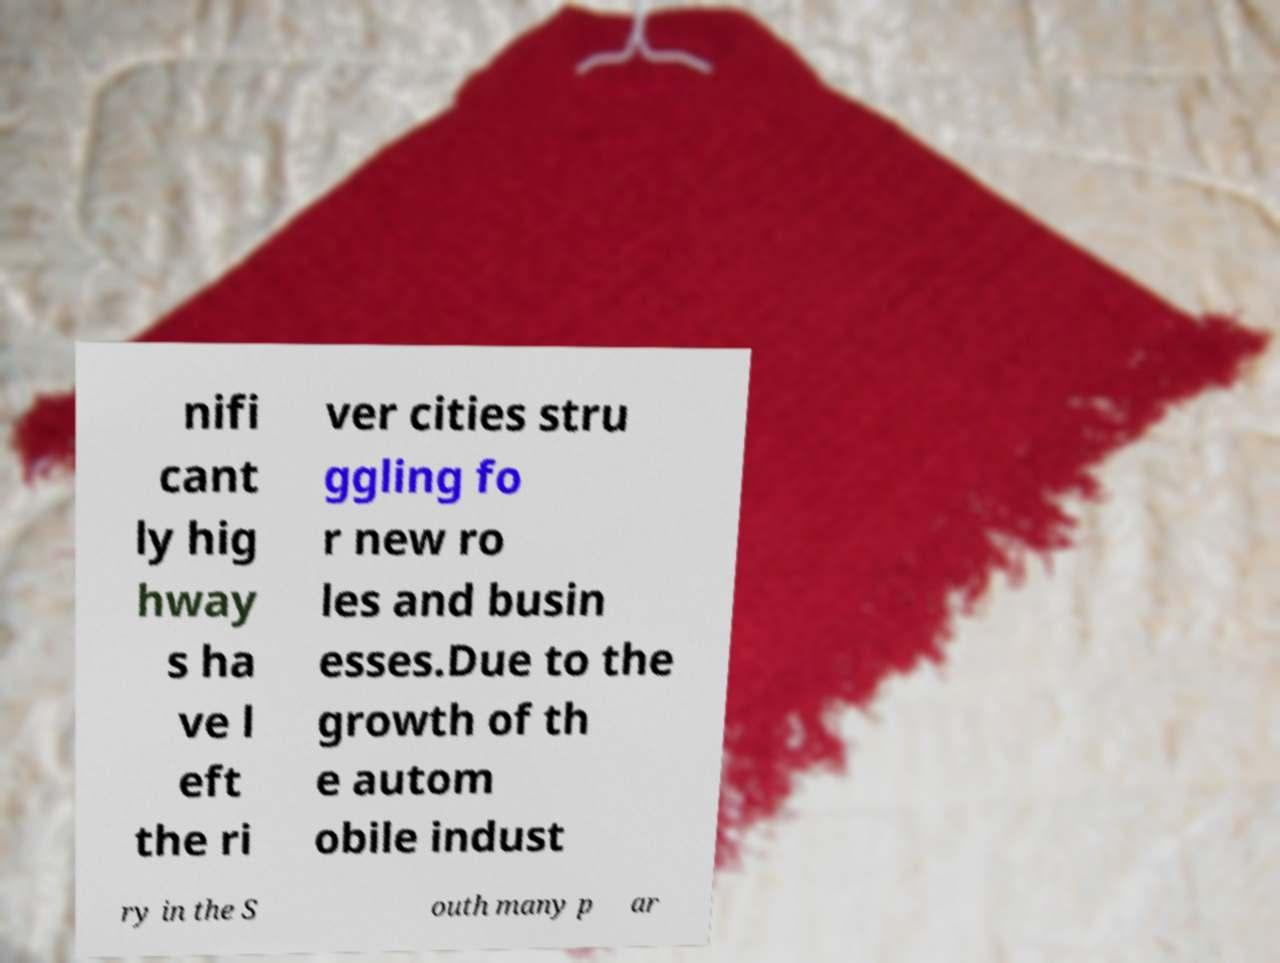Could you extract and type out the text from this image? nifi cant ly hig hway s ha ve l eft the ri ver cities stru ggling fo r new ro les and busin esses.Due to the growth of th e autom obile indust ry in the S outh many p ar 